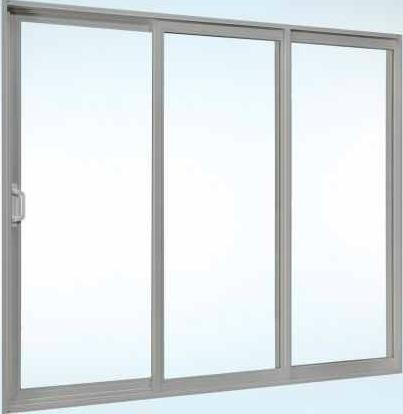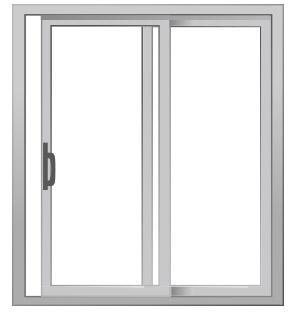The first image is the image on the left, the second image is the image on the right. Assess this claim about the two images: "In the image to the right, the window's handle is black, and large enough for a solid grip.". Correct or not? Answer yes or no. Yes. 